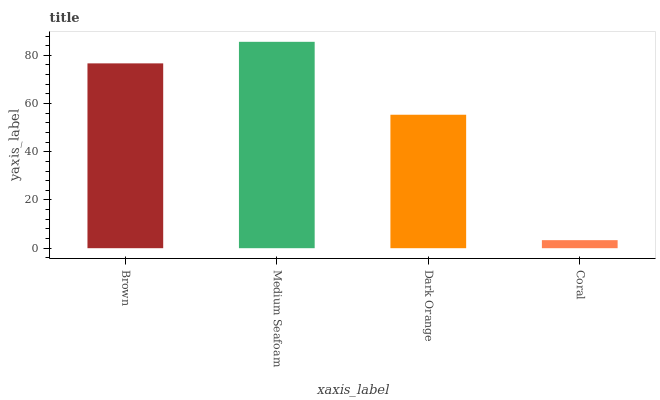Is Coral the minimum?
Answer yes or no. Yes. Is Medium Seafoam the maximum?
Answer yes or no. Yes. Is Dark Orange the minimum?
Answer yes or no. No. Is Dark Orange the maximum?
Answer yes or no. No. Is Medium Seafoam greater than Dark Orange?
Answer yes or no. Yes. Is Dark Orange less than Medium Seafoam?
Answer yes or no. Yes. Is Dark Orange greater than Medium Seafoam?
Answer yes or no. No. Is Medium Seafoam less than Dark Orange?
Answer yes or no. No. Is Brown the high median?
Answer yes or no. Yes. Is Dark Orange the low median?
Answer yes or no. Yes. Is Medium Seafoam the high median?
Answer yes or no. No. Is Coral the low median?
Answer yes or no. No. 